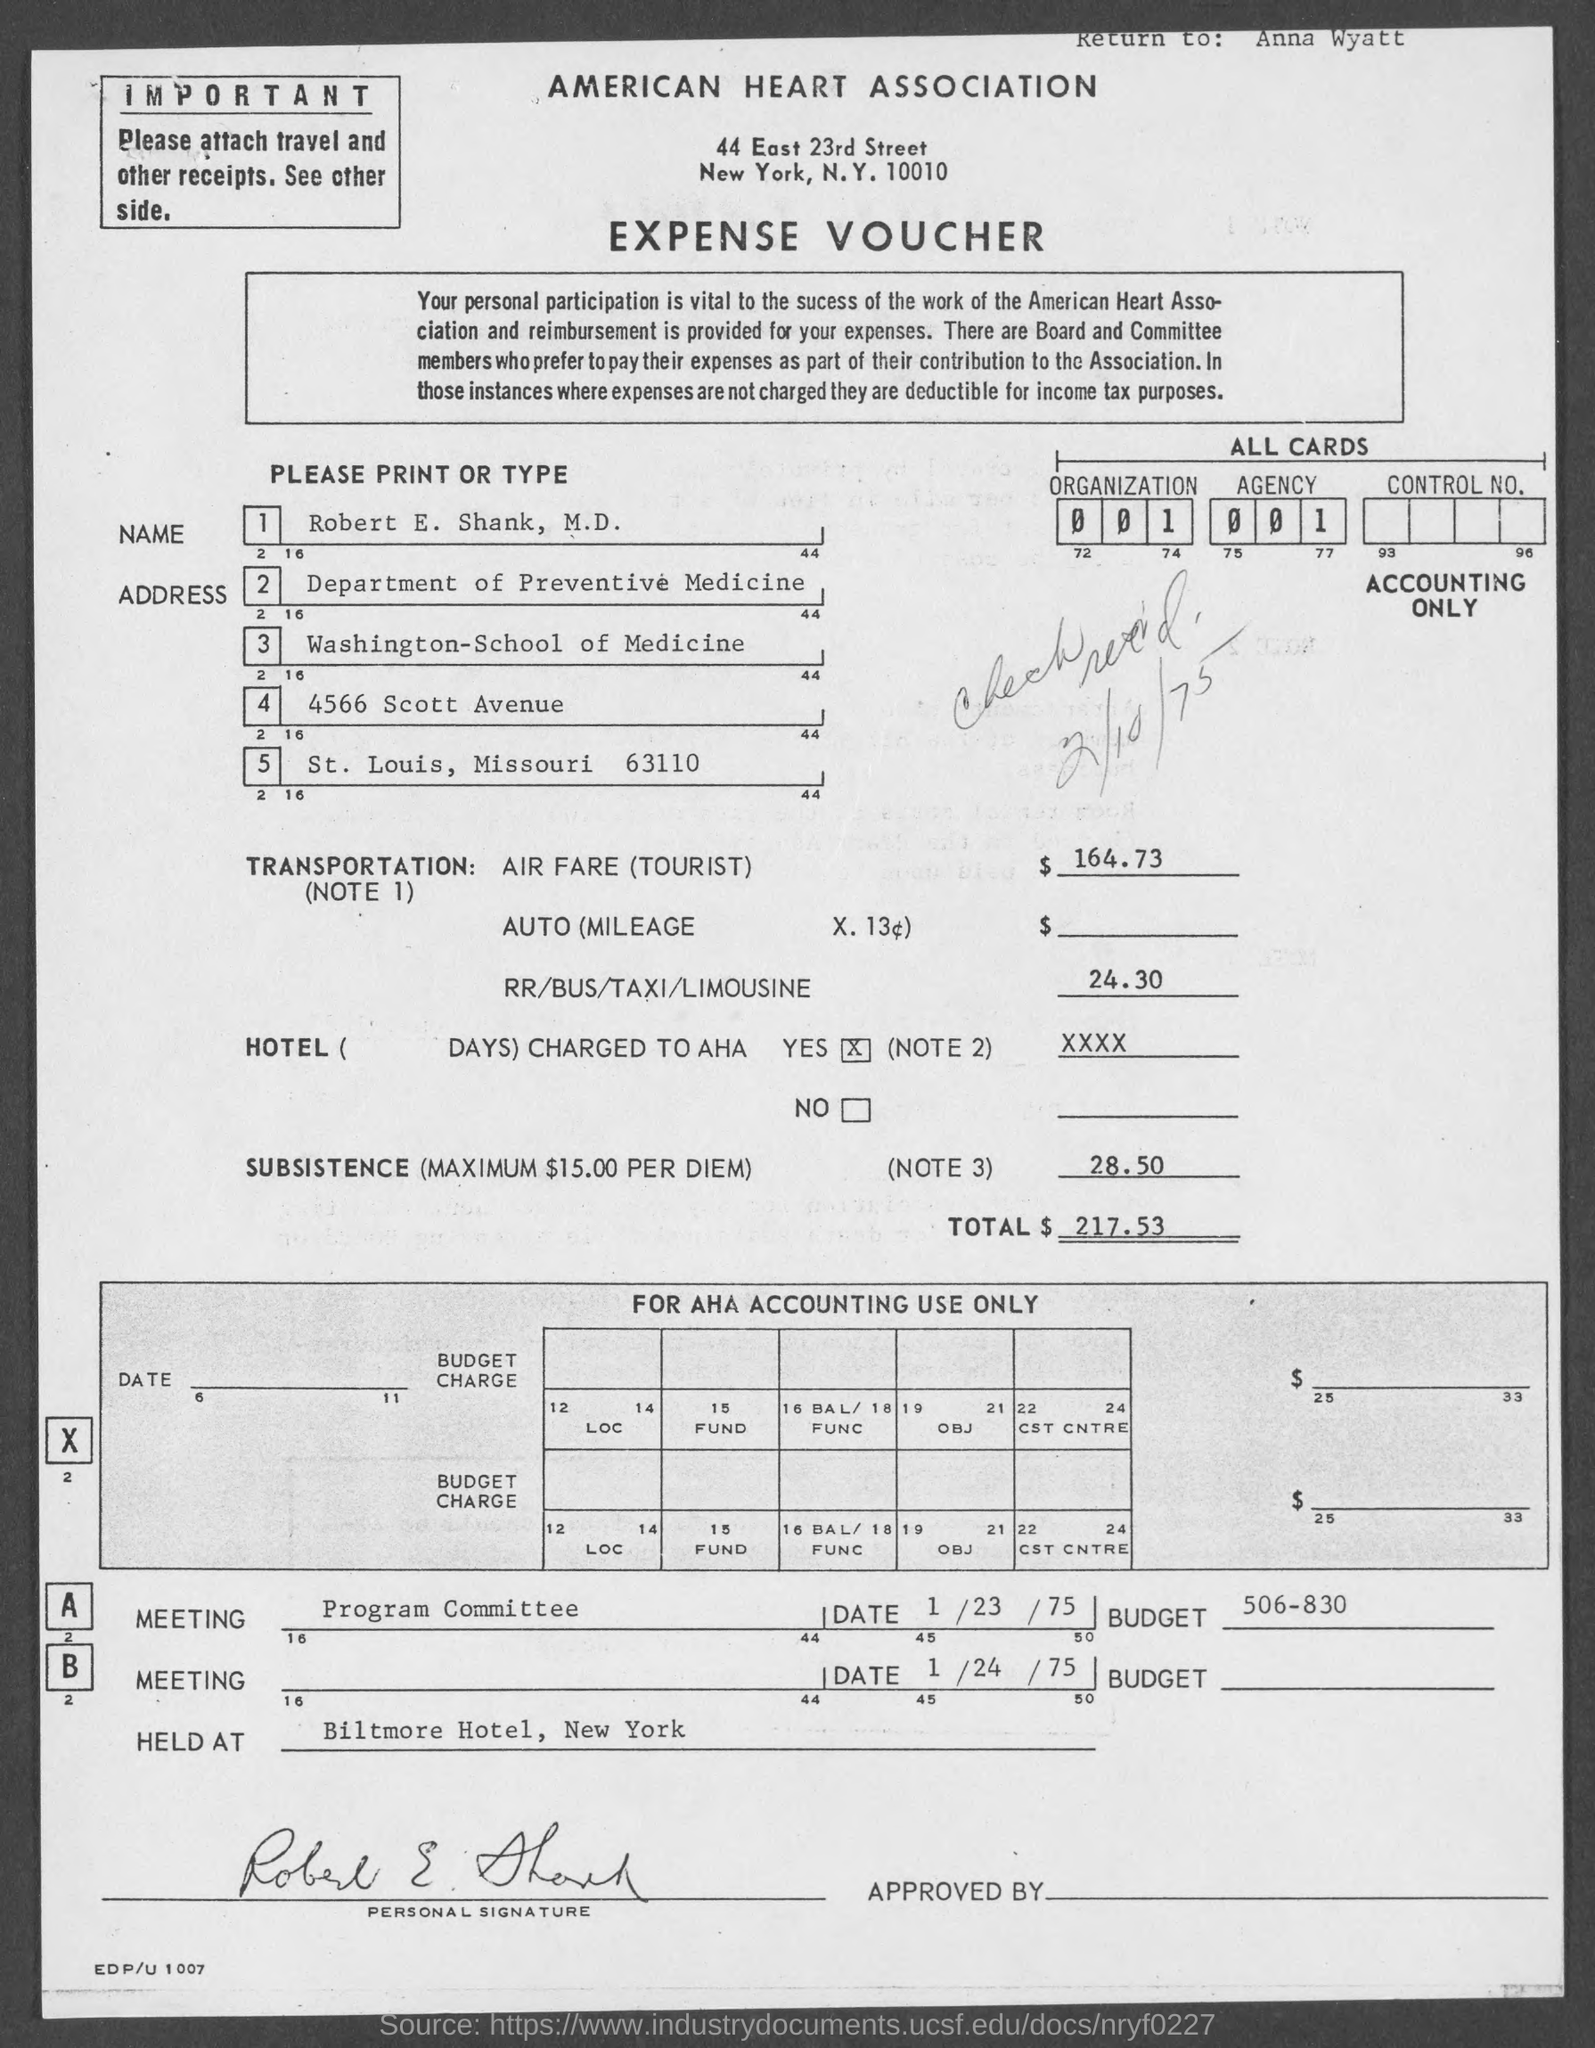List a handful of essential elements in this visual. This is an expense voucher. The program committee is scheduled to meet on January 23, 1975. The American Heart Association is mentioned. The amount of air fare for a tourist is $164.73. 